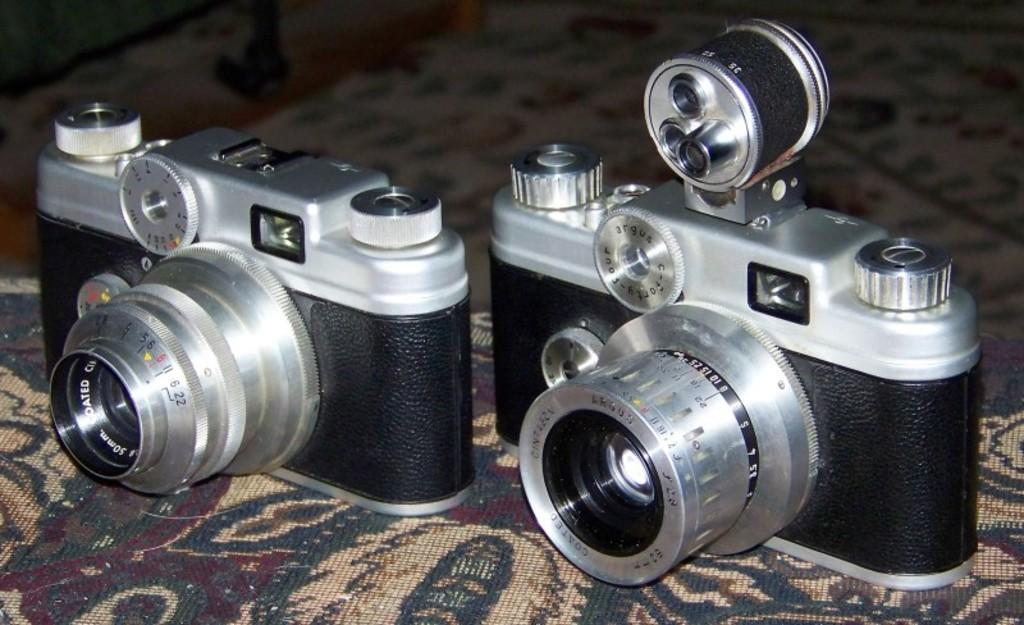What objects are present in the image? There are two cameras, a carpet, hens, and buttons in the image. Where are the cameras located? The cameras are placed on a carpet in the image. What type of animals can be seen in the image? There are hens in the image. What additional feature can be seen on the cameras? There are buttons on the cameras in the image. What type of jeans can be seen on the hens in the image? There are no jeans present in the image; the hens are not wearing any clothing. 